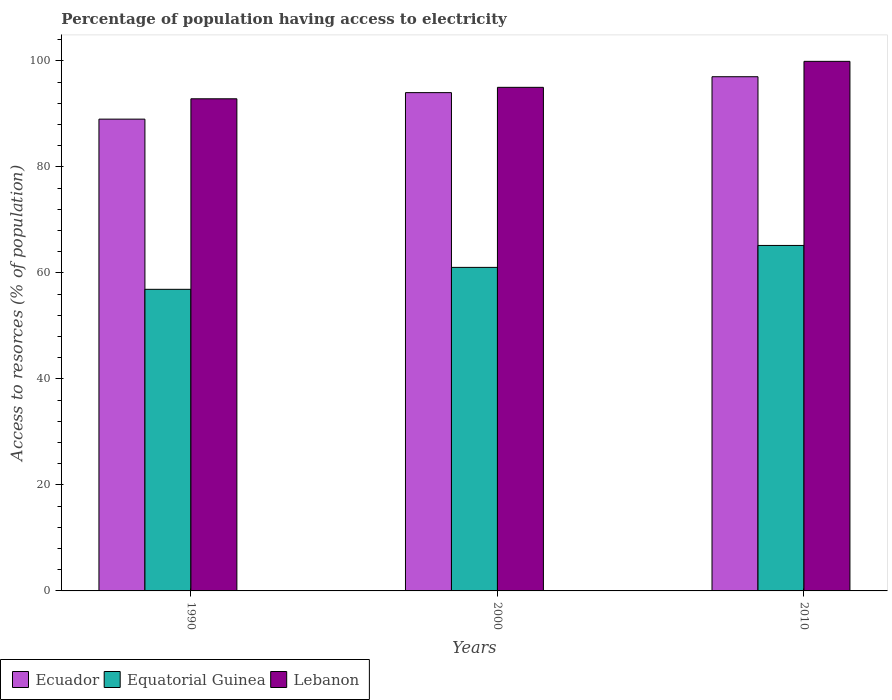Are the number of bars on each tick of the X-axis equal?
Give a very brief answer. Yes. In how many cases, is the number of bars for a given year not equal to the number of legend labels?
Your response must be concise. 0. What is the percentage of population having access to electricity in Ecuador in 2000?
Ensure brevity in your answer.  94. Across all years, what is the maximum percentage of population having access to electricity in Equatorial Guinea?
Your answer should be very brief. 65.17. Across all years, what is the minimum percentage of population having access to electricity in Equatorial Guinea?
Your answer should be very brief. 56.89. In which year was the percentage of population having access to electricity in Ecuador maximum?
Your answer should be compact. 2010. What is the total percentage of population having access to electricity in Equatorial Guinea in the graph?
Give a very brief answer. 183.1. What is the difference between the percentage of population having access to electricity in Equatorial Guinea in 2000 and that in 2010?
Give a very brief answer. -4.14. What is the difference between the percentage of population having access to electricity in Ecuador in 2000 and the percentage of population having access to electricity in Equatorial Guinea in 2010?
Your response must be concise. 28.83. What is the average percentage of population having access to electricity in Ecuador per year?
Your answer should be very brief. 93.33. In the year 1990, what is the difference between the percentage of population having access to electricity in Equatorial Guinea and percentage of population having access to electricity in Lebanon?
Offer a very short reply. -35.94. What is the ratio of the percentage of population having access to electricity in Equatorial Guinea in 1990 to that in 2010?
Make the answer very short. 0.87. Is the percentage of population having access to electricity in Ecuador in 1990 less than that in 2010?
Offer a very short reply. Yes. Is the difference between the percentage of population having access to electricity in Equatorial Guinea in 1990 and 2000 greater than the difference between the percentage of population having access to electricity in Lebanon in 1990 and 2000?
Provide a short and direct response. No. What is the difference between the highest and the lowest percentage of population having access to electricity in Lebanon?
Offer a terse response. 7.06. Is the sum of the percentage of population having access to electricity in Equatorial Guinea in 1990 and 2000 greater than the maximum percentage of population having access to electricity in Ecuador across all years?
Your response must be concise. Yes. What does the 3rd bar from the left in 2000 represents?
Provide a succinct answer. Lebanon. What does the 3rd bar from the right in 2000 represents?
Offer a terse response. Ecuador. Is it the case that in every year, the sum of the percentage of population having access to electricity in Ecuador and percentage of population having access to electricity in Equatorial Guinea is greater than the percentage of population having access to electricity in Lebanon?
Give a very brief answer. Yes. How many years are there in the graph?
Keep it short and to the point. 3. What is the difference between two consecutive major ticks on the Y-axis?
Give a very brief answer. 20. Are the values on the major ticks of Y-axis written in scientific E-notation?
Provide a succinct answer. No. Does the graph contain any zero values?
Offer a terse response. No. Does the graph contain grids?
Give a very brief answer. No. How are the legend labels stacked?
Keep it short and to the point. Horizontal. What is the title of the graph?
Keep it short and to the point. Percentage of population having access to electricity. Does "Middle East & North Africa (all income levels)" appear as one of the legend labels in the graph?
Your answer should be compact. No. What is the label or title of the X-axis?
Provide a short and direct response. Years. What is the label or title of the Y-axis?
Provide a short and direct response. Access to resorces (% of population). What is the Access to resorces (% of population) of Ecuador in 1990?
Provide a short and direct response. 89. What is the Access to resorces (% of population) of Equatorial Guinea in 1990?
Offer a terse response. 56.89. What is the Access to resorces (% of population) in Lebanon in 1990?
Offer a terse response. 92.84. What is the Access to resorces (% of population) of Ecuador in 2000?
Ensure brevity in your answer.  94. What is the Access to resorces (% of population) of Equatorial Guinea in 2000?
Keep it short and to the point. 61.03. What is the Access to resorces (% of population) of Lebanon in 2000?
Give a very brief answer. 95. What is the Access to resorces (% of population) in Ecuador in 2010?
Keep it short and to the point. 97. What is the Access to resorces (% of population) in Equatorial Guinea in 2010?
Your answer should be very brief. 65.17. What is the Access to resorces (% of population) in Lebanon in 2010?
Keep it short and to the point. 99.9. Across all years, what is the maximum Access to resorces (% of population) of Ecuador?
Keep it short and to the point. 97. Across all years, what is the maximum Access to resorces (% of population) in Equatorial Guinea?
Make the answer very short. 65.17. Across all years, what is the maximum Access to resorces (% of population) of Lebanon?
Offer a very short reply. 99.9. Across all years, what is the minimum Access to resorces (% of population) of Ecuador?
Provide a short and direct response. 89. Across all years, what is the minimum Access to resorces (% of population) of Equatorial Guinea?
Provide a succinct answer. 56.89. Across all years, what is the minimum Access to resorces (% of population) in Lebanon?
Your response must be concise. 92.84. What is the total Access to resorces (% of population) in Ecuador in the graph?
Keep it short and to the point. 280. What is the total Access to resorces (% of population) in Equatorial Guinea in the graph?
Your answer should be very brief. 183.1. What is the total Access to resorces (% of population) of Lebanon in the graph?
Offer a terse response. 287.74. What is the difference between the Access to resorces (% of population) in Ecuador in 1990 and that in 2000?
Offer a terse response. -5. What is the difference between the Access to resorces (% of population) in Equatorial Guinea in 1990 and that in 2000?
Make the answer very short. -4.14. What is the difference between the Access to resorces (% of population) of Lebanon in 1990 and that in 2000?
Ensure brevity in your answer.  -2.16. What is the difference between the Access to resorces (% of population) of Equatorial Guinea in 1990 and that in 2010?
Offer a very short reply. -8.28. What is the difference between the Access to resorces (% of population) in Lebanon in 1990 and that in 2010?
Provide a succinct answer. -7.06. What is the difference between the Access to resorces (% of population) in Ecuador in 2000 and that in 2010?
Make the answer very short. -3. What is the difference between the Access to resorces (% of population) of Equatorial Guinea in 2000 and that in 2010?
Keep it short and to the point. -4.14. What is the difference between the Access to resorces (% of population) of Lebanon in 2000 and that in 2010?
Provide a succinct answer. -4.9. What is the difference between the Access to resorces (% of population) of Ecuador in 1990 and the Access to resorces (% of population) of Equatorial Guinea in 2000?
Offer a terse response. 27.97. What is the difference between the Access to resorces (% of population) of Ecuador in 1990 and the Access to resorces (% of population) of Lebanon in 2000?
Keep it short and to the point. -6. What is the difference between the Access to resorces (% of population) of Equatorial Guinea in 1990 and the Access to resorces (% of population) of Lebanon in 2000?
Offer a terse response. -38.11. What is the difference between the Access to resorces (% of population) in Ecuador in 1990 and the Access to resorces (% of population) in Equatorial Guinea in 2010?
Ensure brevity in your answer.  23.83. What is the difference between the Access to resorces (% of population) in Equatorial Guinea in 1990 and the Access to resorces (% of population) in Lebanon in 2010?
Your answer should be very brief. -43.01. What is the difference between the Access to resorces (% of population) in Ecuador in 2000 and the Access to resorces (% of population) in Equatorial Guinea in 2010?
Provide a short and direct response. 28.83. What is the difference between the Access to resorces (% of population) of Equatorial Guinea in 2000 and the Access to resorces (% of population) of Lebanon in 2010?
Your answer should be compact. -38.87. What is the average Access to resorces (% of population) of Ecuador per year?
Provide a succinct answer. 93.33. What is the average Access to resorces (% of population) of Equatorial Guinea per year?
Provide a succinct answer. 61.03. What is the average Access to resorces (% of population) in Lebanon per year?
Provide a succinct answer. 95.91. In the year 1990, what is the difference between the Access to resorces (% of population) of Ecuador and Access to resorces (% of population) of Equatorial Guinea?
Provide a succinct answer. 32.11. In the year 1990, what is the difference between the Access to resorces (% of population) in Ecuador and Access to resorces (% of population) in Lebanon?
Your response must be concise. -3.84. In the year 1990, what is the difference between the Access to resorces (% of population) of Equatorial Guinea and Access to resorces (% of population) of Lebanon?
Offer a very short reply. -35.94. In the year 2000, what is the difference between the Access to resorces (% of population) in Ecuador and Access to resorces (% of population) in Equatorial Guinea?
Your answer should be very brief. 32.97. In the year 2000, what is the difference between the Access to resorces (% of population) in Ecuador and Access to resorces (% of population) in Lebanon?
Make the answer very short. -1. In the year 2000, what is the difference between the Access to resorces (% of population) in Equatorial Guinea and Access to resorces (% of population) in Lebanon?
Your answer should be very brief. -33.97. In the year 2010, what is the difference between the Access to resorces (% of population) in Ecuador and Access to resorces (% of population) in Equatorial Guinea?
Make the answer very short. 31.83. In the year 2010, what is the difference between the Access to resorces (% of population) in Equatorial Guinea and Access to resorces (% of population) in Lebanon?
Your response must be concise. -34.73. What is the ratio of the Access to resorces (% of population) in Ecuador in 1990 to that in 2000?
Offer a terse response. 0.95. What is the ratio of the Access to resorces (% of population) in Equatorial Guinea in 1990 to that in 2000?
Your response must be concise. 0.93. What is the ratio of the Access to resorces (% of population) of Lebanon in 1990 to that in 2000?
Make the answer very short. 0.98. What is the ratio of the Access to resorces (% of population) of Ecuador in 1990 to that in 2010?
Offer a very short reply. 0.92. What is the ratio of the Access to resorces (% of population) in Equatorial Guinea in 1990 to that in 2010?
Ensure brevity in your answer.  0.87. What is the ratio of the Access to resorces (% of population) in Lebanon in 1990 to that in 2010?
Provide a succinct answer. 0.93. What is the ratio of the Access to resorces (% of population) in Ecuador in 2000 to that in 2010?
Provide a succinct answer. 0.97. What is the ratio of the Access to resorces (% of population) of Equatorial Guinea in 2000 to that in 2010?
Your answer should be very brief. 0.94. What is the ratio of the Access to resorces (% of population) of Lebanon in 2000 to that in 2010?
Ensure brevity in your answer.  0.95. What is the difference between the highest and the second highest Access to resorces (% of population) of Ecuador?
Make the answer very short. 3. What is the difference between the highest and the second highest Access to resorces (% of population) in Equatorial Guinea?
Provide a succinct answer. 4.14. What is the difference between the highest and the lowest Access to resorces (% of population) in Equatorial Guinea?
Your response must be concise. 8.28. What is the difference between the highest and the lowest Access to resorces (% of population) in Lebanon?
Offer a terse response. 7.06. 